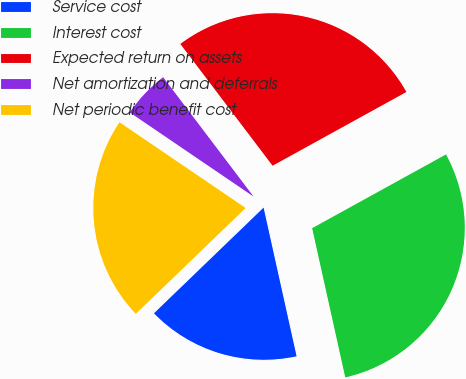Convert chart to OTSL. <chart><loc_0><loc_0><loc_500><loc_500><pie_chart><fcel>Service cost<fcel>Interest cost<fcel>Expected return on assets<fcel>Net amortization and deferrals<fcel>Net periodic benefit cost<nl><fcel>16.27%<fcel>29.54%<fcel>27.3%<fcel>5.18%<fcel>21.71%<nl></chart> 